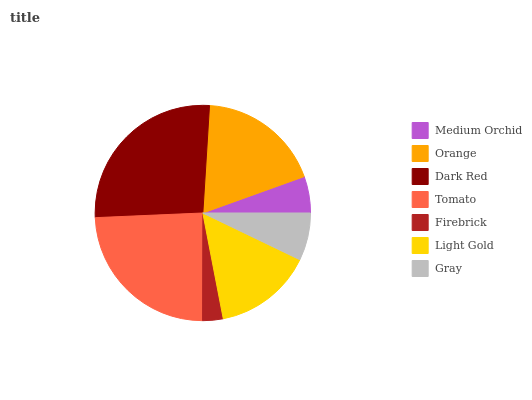Is Firebrick the minimum?
Answer yes or no. Yes. Is Dark Red the maximum?
Answer yes or no. Yes. Is Orange the minimum?
Answer yes or no. No. Is Orange the maximum?
Answer yes or no. No. Is Orange greater than Medium Orchid?
Answer yes or no. Yes. Is Medium Orchid less than Orange?
Answer yes or no. Yes. Is Medium Orchid greater than Orange?
Answer yes or no. No. Is Orange less than Medium Orchid?
Answer yes or no. No. Is Light Gold the high median?
Answer yes or no. Yes. Is Light Gold the low median?
Answer yes or no. Yes. Is Gray the high median?
Answer yes or no. No. Is Tomato the low median?
Answer yes or no. No. 